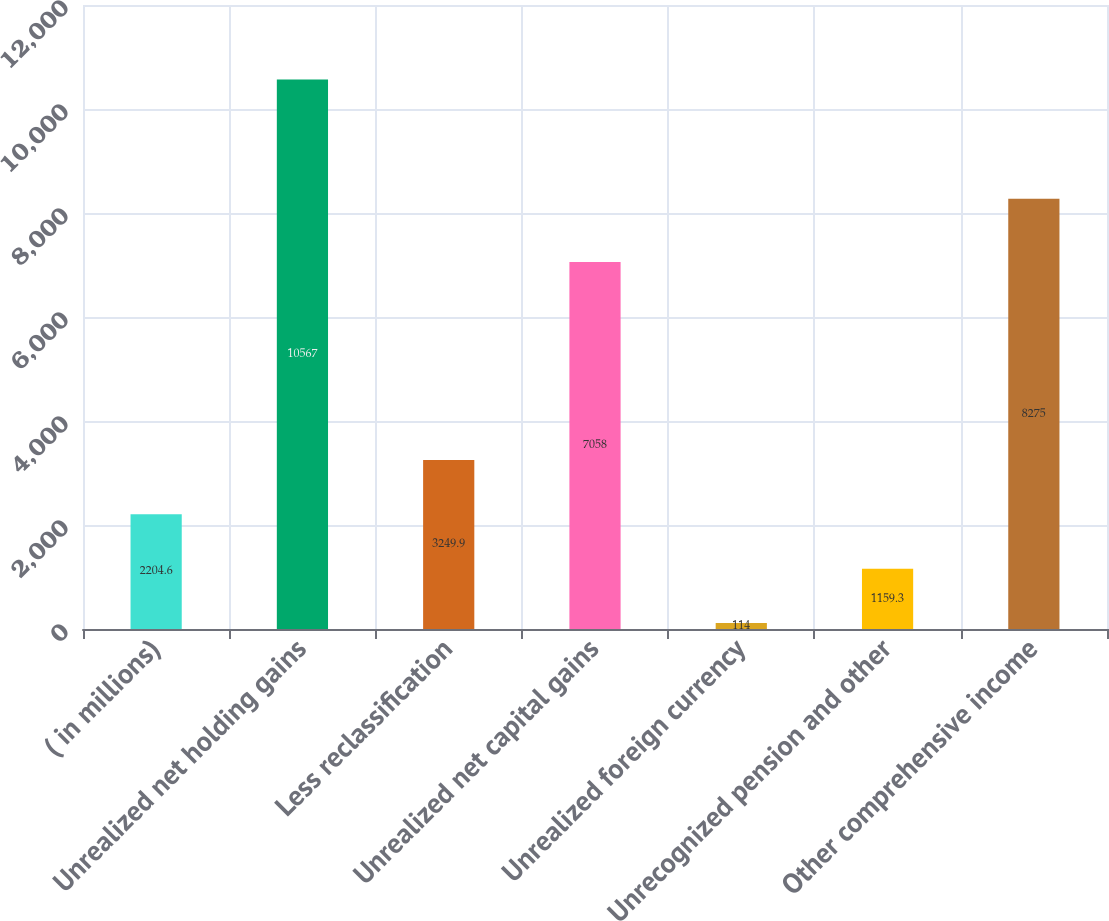Convert chart. <chart><loc_0><loc_0><loc_500><loc_500><bar_chart><fcel>( in millions)<fcel>Unrealized net holding gains<fcel>Less reclassification<fcel>Unrealized net capital gains<fcel>Unrealized foreign currency<fcel>Unrecognized pension and other<fcel>Other comprehensive income<nl><fcel>2204.6<fcel>10567<fcel>3249.9<fcel>7058<fcel>114<fcel>1159.3<fcel>8275<nl></chart> 